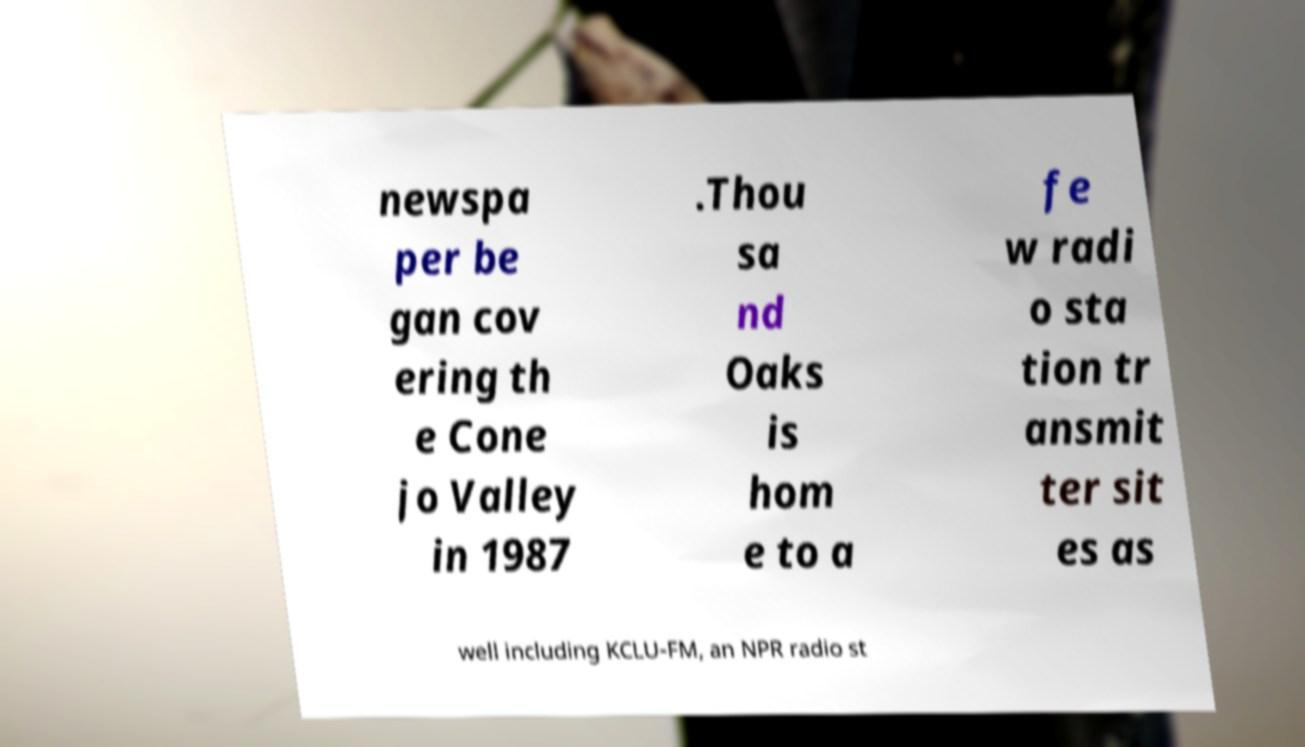Please read and relay the text visible in this image. What does it say? newspa per be gan cov ering th e Cone jo Valley in 1987 .Thou sa nd Oaks is hom e to a fe w radi o sta tion tr ansmit ter sit es as well including KCLU-FM, an NPR radio st 